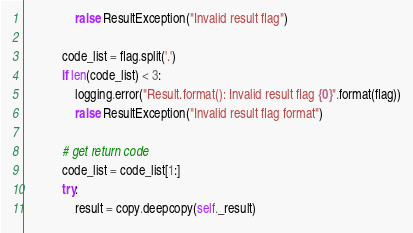Convert code to text. <code><loc_0><loc_0><loc_500><loc_500><_Python_>                raise ResultException("Invalid result flag")

            code_list = flag.split('.')
            if len(code_list) < 3:
                logging.error("Result.format(): Invalid result flag {0}".format(flag))
                raise ResultException("Invalid result flag format")

            # get return code
            code_list = code_list[1:]
            try:
                result = copy.deepcopy(self._result)
</code> 